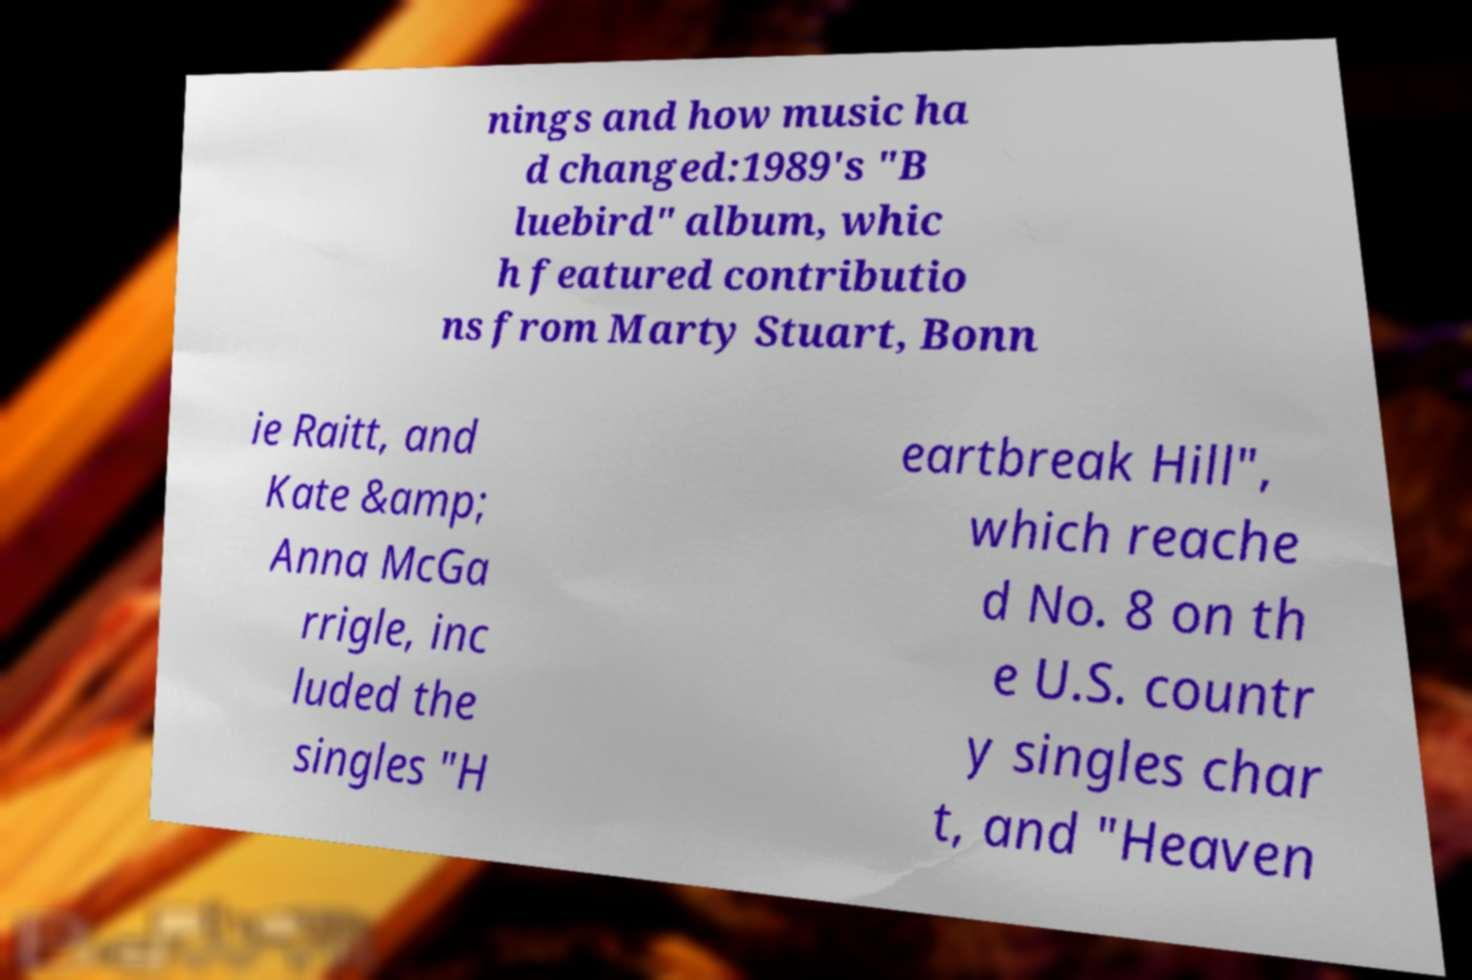Could you extract and type out the text from this image? nings and how music ha d changed:1989's "B luebird" album, whic h featured contributio ns from Marty Stuart, Bonn ie Raitt, and Kate &amp; Anna McGa rrigle, inc luded the singles "H eartbreak Hill", which reache d No. 8 on th e U.S. countr y singles char t, and "Heaven 